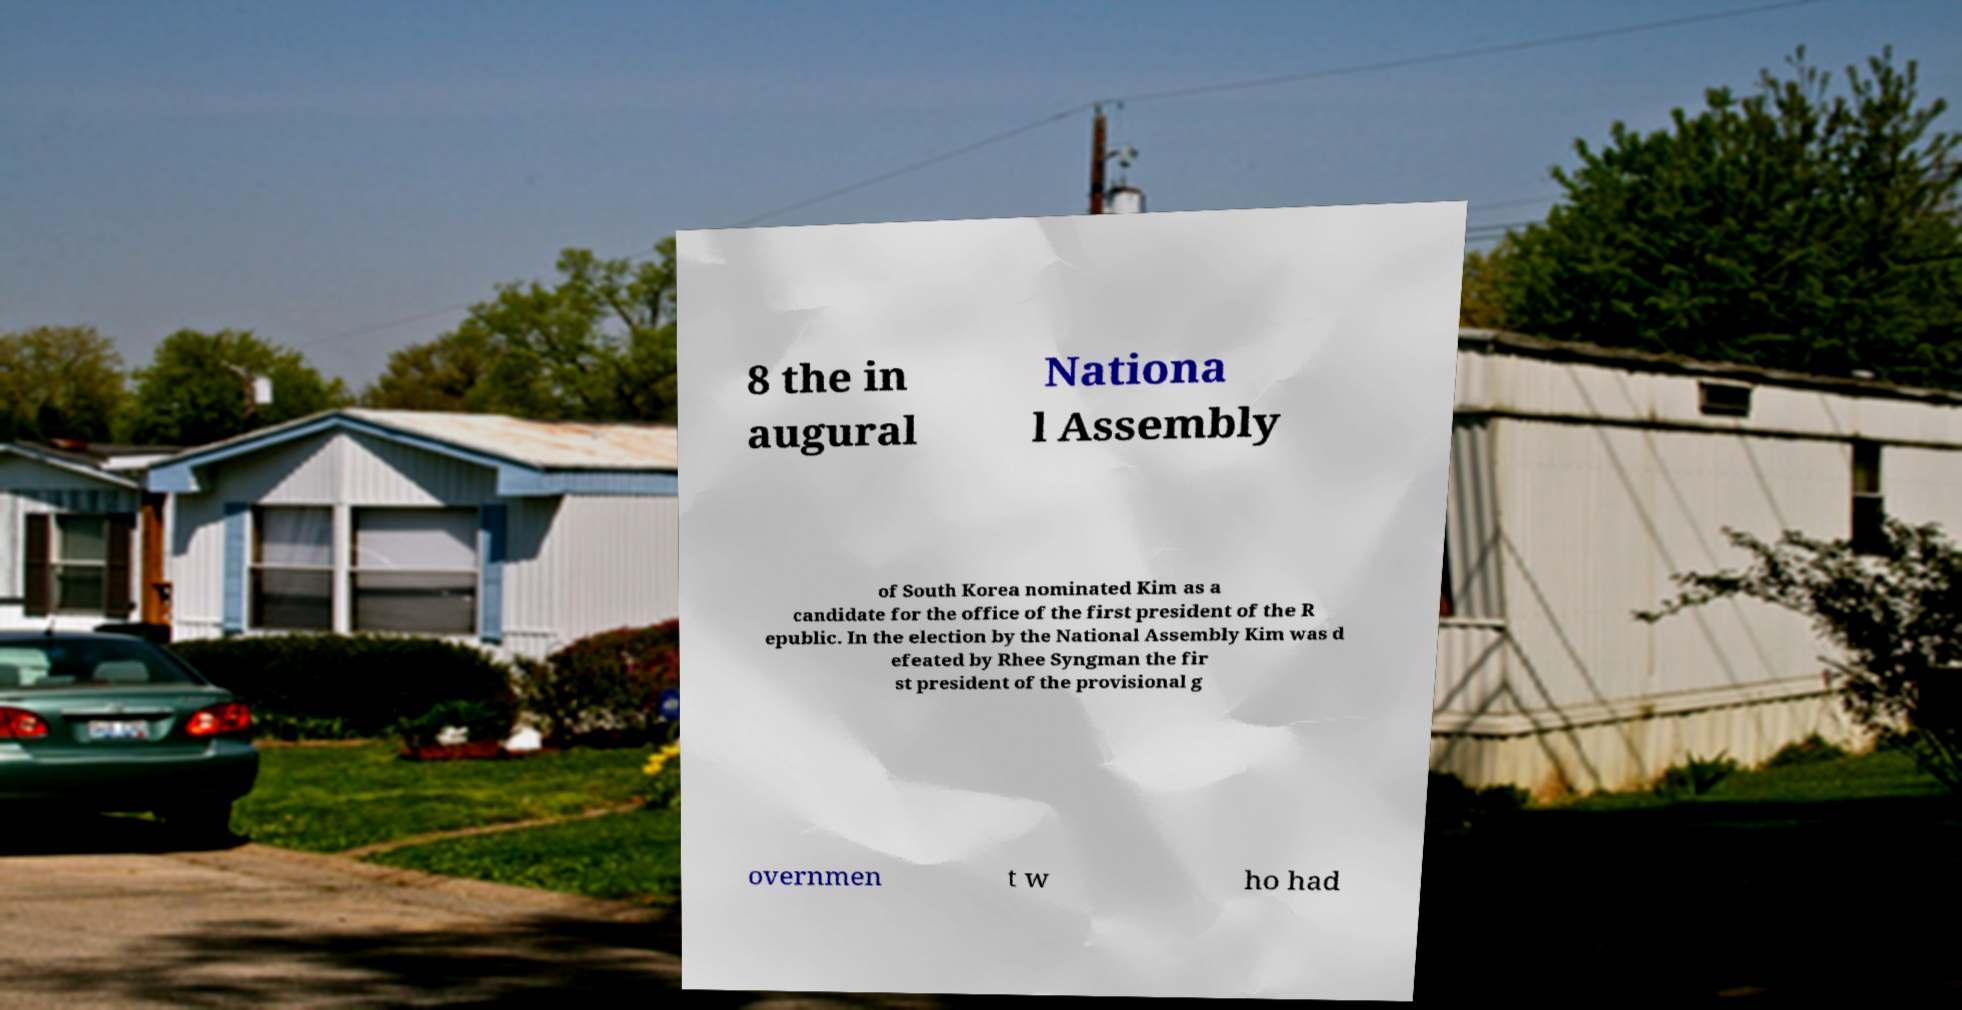There's text embedded in this image that I need extracted. Can you transcribe it verbatim? 8 the in augural Nationa l Assembly of South Korea nominated Kim as a candidate for the office of the first president of the R epublic. In the election by the National Assembly Kim was d efeated by Rhee Syngman the fir st president of the provisional g overnmen t w ho had 